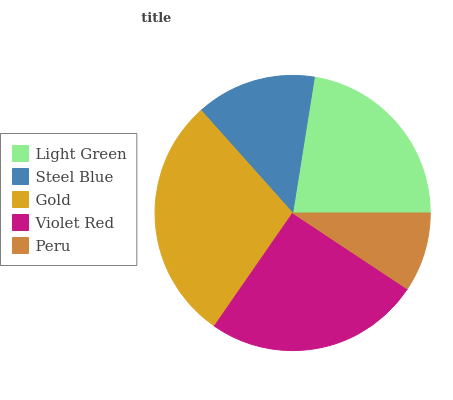Is Peru the minimum?
Answer yes or no. Yes. Is Gold the maximum?
Answer yes or no. Yes. Is Steel Blue the minimum?
Answer yes or no. No. Is Steel Blue the maximum?
Answer yes or no. No. Is Light Green greater than Steel Blue?
Answer yes or no. Yes. Is Steel Blue less than Light Green?
Answer yes or no. Yes. Is Steel Blue greater than Light Green?
Answer yes or no. No. Is Light Green less than Steel Blue?
Answer yes or no. No. Is Light Green the high median?
Answer yes or no. Yes. Is Light Green the low median?
Answer yes or no. Yes. Is Steel Blue the high median?
Answer yes or no. No. Is Peru the low median?
Answer yes or no. No. 